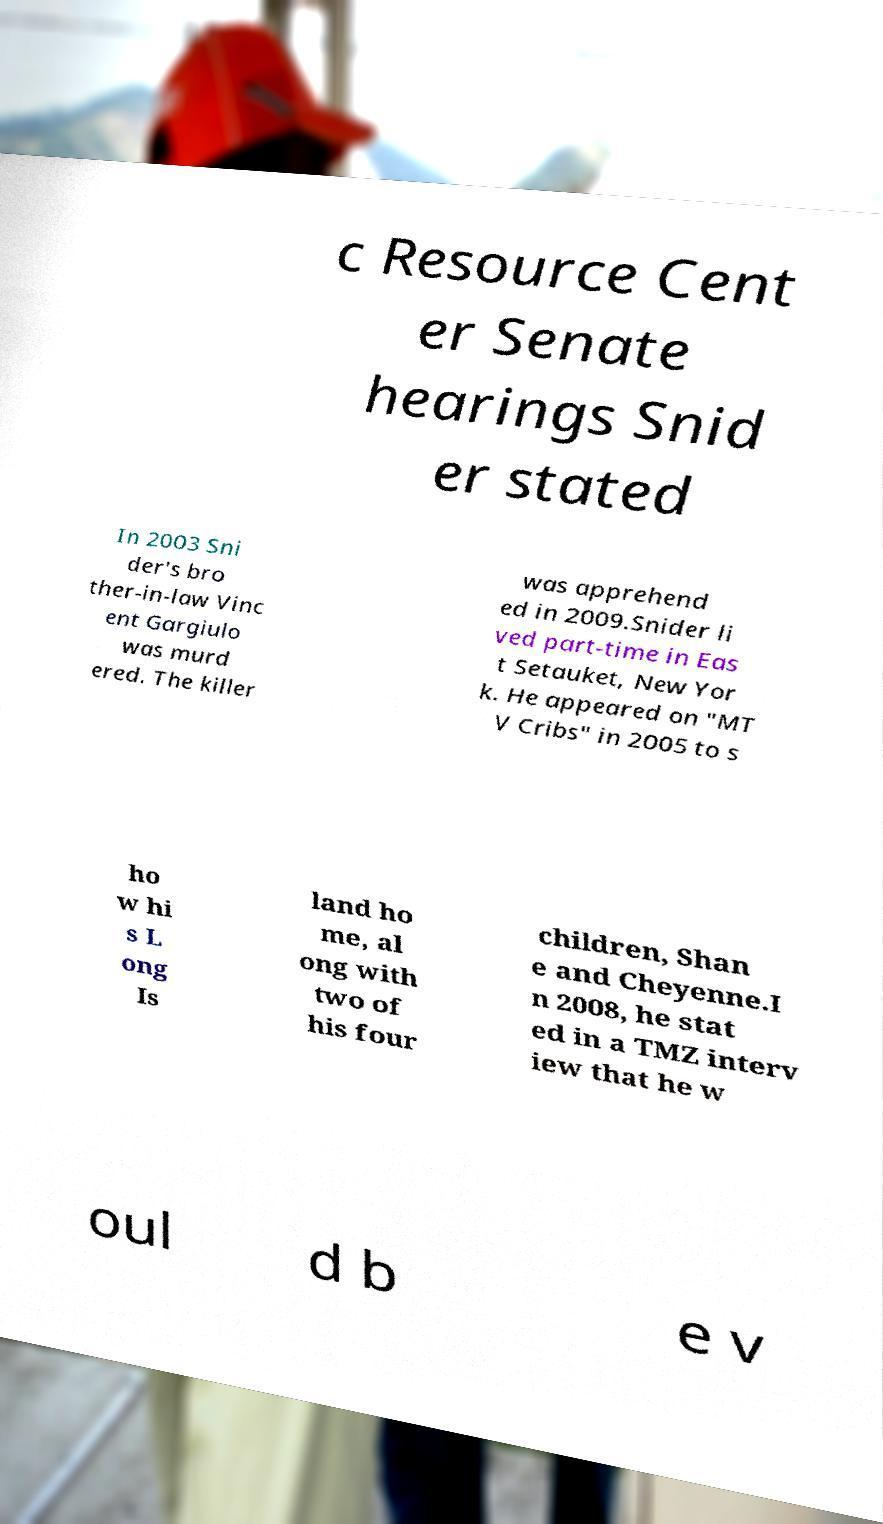Could you extract and type out the text from this image? c Resource Cent er Senate hearings Snid er stated In 2003 Sni der's bro ther-in-law Vinc ent Gargiulo was murd ered. The killer was apprehend ed in 2009.Snider li ved part-time in Eas t Setauket, New Yor k. He appeared on "MT V Cribs" in 2005 to s ho w hi s L ong Is land ho me, al ong with two of his four children, Shan e and Cheyenne.I n 2008, he stat ed in a TMZ interv iew that he w oul d b e v 